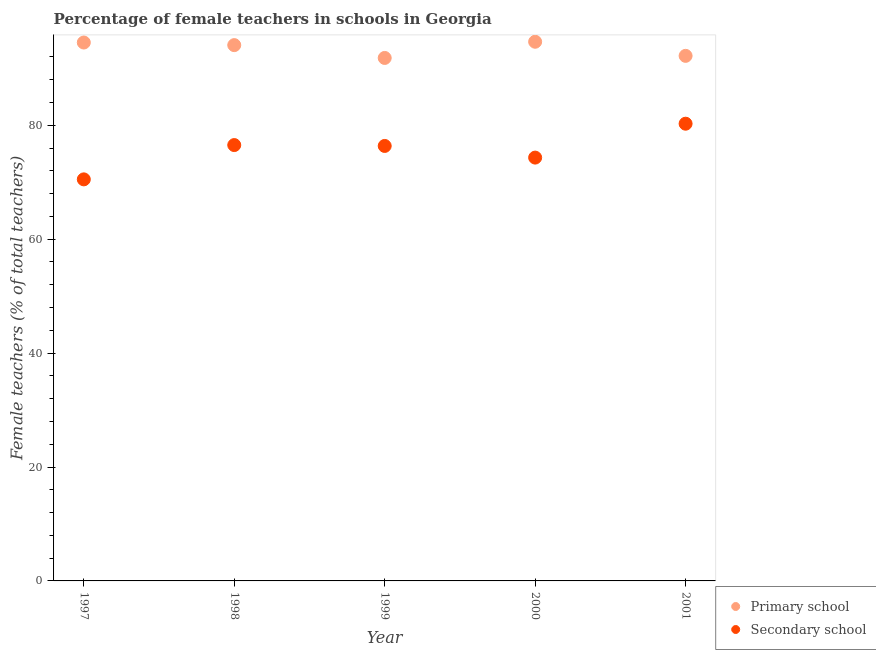What is the percentage of female teachers in primary schools in 1999?
Make the answer very short. 91.83. Across all years, what is the maximum percentage of female teachers in primary schools?
Offer a very short reply. 94.67. Across all years, what is the minimum percentage of female teachers in primary schools?
Offer a terse response. 91.83. In which year was the percentage of female teachers in secondary schools minimum?
Offer a terse response. 1997. What is the total percentage of female teachers in secondary schools in the graph?
Ensure brevity in your answer.  378.03. What is the difference between the percentage of female teachers in primary schools in 1999 and that in 2000?
Your response must be concise. -2.84. What is the difference between the percentage of female teachers in secondary schools in 1997 and the percentage of female teachers in primary schools in 2000?
Provide a succinct answer. -24.16. What is the average percentage of female teachers in secondary schools per year?
Keep it short and to the point. 75.61. In the year 1999, what is the difference between the percentage of female teachers in secondary schools and percentage of female teachers in primary schools?
Ensure brevity in your answer.  -15.45. What is the ratio of the percentage of female teachers in primary schools in 1997 to that in 1998?
Offer a terse response. 1. Is the difference between the percentage of female teachers in primary schools in 1997 and 2000 greater than the difference between the percentage of female teachers in secondary schools in 1997 and 2000?
Keep it short and to the point. Yes. What is the difference between the highest and the second highest percentage of female teachers in primary schools?
Make the answer very short. 0.14. What is the difference between the highest and the lowest percentage of female teachers in secondary schools?
Your answer should be very brief. 9.77. In how many years, is the percentage of female teachers in primary schools greater than the average percentage of female teachers in primary schools taken over all years?
Ensure brevity in your answer.  3. What is the difference between two consecutive major ticks on the Y-axis?
Keep it short and to the point. 20. Are the values on the major ticks of Y-axis written in scientific E-notation?
Make the answer very short. No. Does the graph contain any zero values?
Provide a succinct answer. No. Does the graph contain grids?
Your answer should be compact. No. How many legend labels are there?
Ensure brevity in your answer.  2. How are the legend labels stacked?
Your response must be concise. Vertical. What is the title of the graph?
Provide a succinct answer. Percentage of female teachers in schools in Georgia. Does "Attending school" appear as one of the legend labels in the graph?
Provide a short and direct response. No. What is the label or title of the X-axis?
Keep it short and to the point. Year. What is the label or title of the Y-axis?
Keep it short and to the point. Female teachers (% of total teachers). What is the Female teachers (% of total teachers) in Primary school in 1997?
Provide a short and direct response. 94.54. What is the Female teachers (% of total teachers) of Secondary school in 1997?
Provide a short and direct response. 70.51. What is the Female teachers (% of total teachers) in Primary school in 1998?
Your answer should be very brief. 94.08. What is the Female teachers (% of total teachers) in Secondary school in 1998?
Provide a short and direct response. 76.53. What is the Female teachers (% of total teachers) in Primary school in 1999?
Provide a succinct answer. 91.83. What is the Female teachers (% of total teachers) of Secondary school in 1999?
Offer a very short reply. 76.38. What is the Female teachers (% of total teachers) in Primary school in 2000?
Keep it short and to the point. 94.67. What is the Female teachers (% of total teachers) of Secondary school in 2000?
Ensure brevity in your answer.  74.33. What is the Female teachers (% of total teachers) in Primary school in 2001?
Ensure brevity in your answer.  92.19. What is the Female teachers (% of total teachers) in Secondary school in 2001?
Ensure brevity in your answer.  80.28. Across all years, what is the maximum Female teachers (% of total teachers) of Primary school?
Ensure brevity in your answer.  94.67. Across all years, what is the maximum Female teachers (% of total teachers) of Secondary school?
Provide a succinct answer. 80.28. Across all years, what is the minimum Female teachers (% of total teachers) in Primary school?
Your answer should be compact. 91.83. Across all years, what is the minimum Female teachers (% of total teachers) in Secondary school?
Keep it short and to the point. 70.51. What is the total Female teachers (% of total teachers) of Primary school in the graph?
Keep it short and to the point. 467.31. What is the total Female teachers (% of total teachers) of Secondary school in the graph?
Your answer should be very brief. 378.03. What is the difference between the Female teachers (% of total teachers) of Primary school in 1997 and that in 1998?
Your answer should be compact. 0.46. What is the difference between the Female teachers (% of total teachers) of Secondary school in 1997 and that in 1998?
Provide a succinct answer. -6.02. What is the difference between the Female teachers (% of total teachers) of Primary school in 1997 and that in 1999?
Make the answer very short. 2.71. What is the difference between the Female teachers (% of total teachers) in Secondary school in 1997 and that in 1999?
Ensure brevity in your answer.  -5.87. What is the difference between the Female teachers (% of total teachers) of Primary school in 1997 and that in 2000?
Provide a short and direct response. -0.14. What is the difference between the Female teachers (% of total teachers) of Secondary school in 1997 and that in 2000?
Provide a succinct answer. -3.82. What is the difference between the Female teachers (% of total teachers) in Primary school in 1997 and that in 2001?
Offer a very short reply. 2.34. What is the difference between the Female teachers (% of total teachers) of Secondary school in 1997 and that in 2001?
Your response must be concise. -9.77. What is the difference between the Female teachers (% of total teachers) in Primary school in 1998 and that in 1999?
Your response must be concise. 2.25. What is the difference between the Female teachers (% of total teachers) in Secondary school in 1998 and that in 1999?
Your answer should be compact. 0.15. What is the difference between the Female teachers (% of total teachers) in Primary school in 1998 and that in 2000?
Your answer should be very brief. -0.59. What is the difference between the Female teachers (% of total teachers) of Secondary school in 1998 and that in 2000?
Offer a very short reply. 2.2. What is the difference between the Female teachers (% of total teachers) in Primary school in 1998 and that in 2001?
Give a very brief answer. 1.89. What is the difference between the Female teachers (% of total teachers) in Secondary school in 1998 and that in 2001?
Your answer should be very brief. -3.75. What is the difference between the Female teachers (% of total teachers) in Primary school in 1999 and that in 2000?
Offer a very short reply. -2.84. What is the difference between the Female teachers (% of total teachers) of Secondary school in 1999 and that in 2000?
Make the answer very short. 2.05. What is the difference between the Female teachers (% of total teachers) in Primary school in 1999 and that in 2001?
Your answer should be very brief. -0.37. What is the difference between the Female teachers (% of total teachers) of Secondary school in 1999 and that in 2001?
Provide a short and direct response. -3.91. What is the difference between the Female teachers (% of total teachers) of Primary school in 2000 and that in 2001?
Your answer should be very brief. 2.48. What is the difference between the Female teachers (% of total teachers) of Secondary school in 2000 and that in 2001?
Keep it short and to the point. -5.95. What is the difference between the Female teachers (% of total teachers) in Primary school in 1997 and the Female teachers (% of total teachers) in Secondary school in 1998?
Ensure brevity in your answer.  18. What is the difference between the Female teachers (% of total teachers) of Primary school in 1997 and the Female teachers (% of total teachers) of Secondary school in 1999?
Your response must be concise. 18.16. What is the difference between the Female teachers (% of total teachers) in Primary school in 1997 and the Female teachers (% of total teachers) in Secondary school in 2000?
Your response must be concise. 20.21. What is the difference between the Female teachers (% of total teachers) of Primary school in 1997 and the Female teachers (% of total teachers) of Secondary school in 2001?
Your answer should be compact. 14.25. What is the difference between the Female teachers (% of total teachers) in Primary school in 1998 and the Female teachers (% of total teachers) in Secondary school in 1999?
Your answer should be very brief. 17.7. What is the difference between the Female teachers (% of total teachers) of Primary school in 1998 and the Female teachers (% of total teachers) of Secondary school in 2000?
Your answer should be compact. 19.75. What is the difference between the Female teachers (% of total teachers) of Primary school in 1998 and the Female teachers (% of total teachers) of Secondary school in 2001?
Provide a succinct answer. 13.8. What is the difference between the Female teachers (% of total teachers) of Primary school in 1999 and the Female teachers (% of total teachers) of Secondary school in 2000?
Your answer should be compact. 17.5. What is the difference between the Female teachers (% of total teachers) of Primary school in 1999 and the Female teachers (% of total teachers) of Secondary school in 2001?
Offer a very short reply. 11.55. What is the difference between the Female teachers (% of total teachers) of Primary school in 2000 and the Female teachers (% of total teachers) of Secondary school in 2001?
Your answer should be compact. 14.39. What is the average Female teachers (% of total teachers) of Primary school per year?
Your answer should be compact. 93.46. What is the average Female teachers (% of total teachers) of Secondary school per year?
Your answer should be compact. 75.61. In the year 1997, what is the difference between the Female teachers (% of total teachers) of Primary school and Female teachers (% of total teachers) of Secondary school?
Your response must be concise. 24.03. In the year 1998, what is the difference between the Female teachers (% of total teachers) of Primary school and Female teachers (% of total teachers) of Secondary school?
Your response must be concise. 17.55. In the year 1999, what is the difference between the Female teachers (% of total teachers) of Primary school and Female teachers (% of total teachers) of Secondary school?
Keep it short and to the point. 15.45. In the year 2000, what is the difference between the Female teachers (% of total teachers) in Primary school and Female teachers (% of total teachers) in Secondary school?
Keep it short and to the point. 20.34. In the year 2001, what is the difference between the Female teachers (% of total teachers) in Primary school and Female teachers (% of total teachers) in Secondary school?
Your response must be concise. 11.91. What is the ratio of the Female teachers (% of total teachers) in Secondary school in 1997 to that in 1998?
Ensure brevity in your answer.  0.92. What is the ratio of the Female teachers (% of total teachers) in Primary school in 1997 to that in 1999?
Make the answer very short. 1.03. What is the ratio of the Female teachers (% of total teachers) of Secondary school in 1997 to that in 1999?
Provide a succinct answer. 0.92. What is the ratio of the Female teachers (% of total teachers) of Primary school in 1997 to that in 2000?
Your answer should be compact. 1. What is the ratio of the Female teachers (% of total teachers) in Secondary school in 1997 to that in 2000?
Provide a succinct answer. 0.95. What is the ratio of the Female teachers (% of total teachers) of Primary school in 1997 to that in 2001?
Give a very brief answer. 1.03. What is the ratio of the Female teachers (% of total teachers) of Secondary school in 1997 to that in 2001?
Keep it short and to the point. 0.88. What is the ratio of the Female teachers (% of total teachers) in Primary school in 1998 to that in 1999?
Your answer should be very brief. 1.02. What is the ratio of the Female teachers (% of total teachers) in Secondary school in 1998 to that in 1999?
Ensure brevity in your answer.  1. What is the ratio of the Female teachers (% of total teachers) in Primary school in 1998 to that in 2000?
Your answer should be compact. 0.99. What is the ratio of the Female teachers (% of total teachers) in Secondary school in 1998 to that in 2000?
Provide a short and direct response. 1.03. What is the ratio of the Female teachers (% of total teachers) of Primary school in 1998 to that in 2001?
Make the answer very short. 1.02. What is the ratio of the Female teachers (% of total teachers) of Secondary school in 1998 to that in 2001?
Keep it short and to the point. 0.95. What is the ratio of the Female teachers (% of total teachers) in Secondary school in 1999 to that in 2000?
Offer a very short reply. 1.03. What is the ratio of the Female teachers (% of total teachers) of Secondary school in 1999 to that in 2001?
Ensure brevity in your answer.  0.95. What is the ratio of the Female teachers (% of total teachers) of Primary school in 2000 to that in 2001?
Your answer should be compact. 1.03. What is the ratio of the Female teachers (% of total teachers) in Secondary school in 2000 to that in 2001?
Provide a succinct answer. 0.93. What is the difference between the highest and the second highest Female teachers (% of total teachers) in Primary school?
Make the answer very short. 0.14. What is the difference between the highest and the second highest Female teachers (% of total teachers) in Secondary school?
Make the answer very short. 3.75. What is the difference between the highest and the lowest Female teachers (% of total teachers) in Primary school?
Keep it short and to the point. 2.84. What is the difference between the highest and the lowest Female teachers (% of total teachers) of Secondary school?
Give a very brief answer. 9.77. 